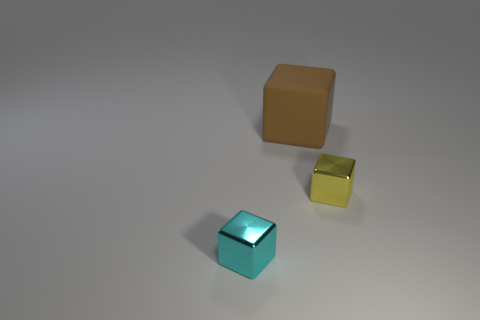Add 3 large cyan metallic objects. How many objects exist? 6 Subtract all big brown blocks. Subtract all tiny yellow things. How many objects are left? 1 Add 2 small cubes. How many small cubes are left? 4 Add 1 large brown spheres. How many large brown spheres exist? 1 Subtract all tiny yellow metallic cubes. How many cubes are left? 2 Subtract 0 green cubes. How many objects are left? 3 Subtract all green blocks. Subtract all brown spheres. How many blocks are left? 3 Subtract all blue cylinders. How many blue blocks are left? 0 